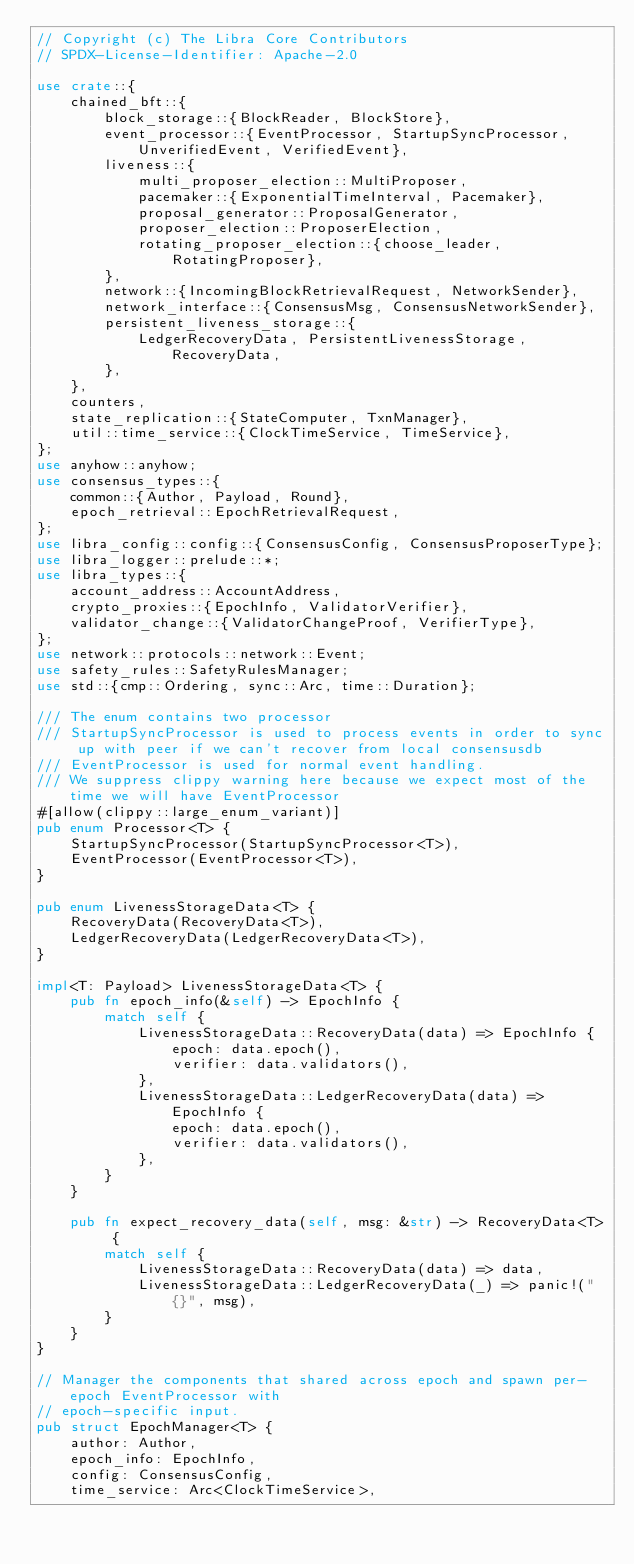<code> <loc_0><loc_0><loc_500><loc_500><_Rust_>// Copyright (c) The Libra Core Contributors
// SPDX-License-Identifier: Apache-2.0

use crate::{
    chained_bft::{
        block_storage::{BlockReader, BlockStore},
        event_processor::{EventProcessor, StartupSyncProcessor, UnverifiedEvent, VerifiedEvent},
        liveness::{
            multi_proposer_election::MultiProposer,
            pacemaker::{ExponentialTimeInterval, Pacemaker},
            proposal_generator::ProposalGenerator,
            proposer_election::ProposerElection,
            rotating_proposer_election::{choose_leader, RotatingProposer},
        },
        network::{IncomingBlockRetrievalRequest, NetworkSender},
        network_interface::{ConsensusMsg, ConsensusNetworkSender},
        persistent_liveness_storage::{
            LedgerRecoveryData, PersistentLivenessStorage, RecoveryData,
        },
    },
    counters,
    state_replication::{StateComputer, TxnManager},
    util::time_service::{ClockTimeService, TimeService},
};
use anyhow::anyhow;
use consensus_types::{
    common::{Author, Payload, Round},
    epoch_retrieval::EpochRetrievalRequest,
};
use libra_config::config::{ConsensusConfig, ConsensusProposerType};
use libra_logger::prelude::*;
use libra_types::{
    account_address::AccountAddress,
    crypto_proxies::{EpochInfo, ValidatorVerifier},
    validator_change::{ValidatorChangeProof, VerifierType},
};
use network::protocols::network::Event;
use safety_rules::SafetyRulesManager;
use std::{cmp::Ordering, sync::Arc, time::Duration};

/// The enum contains two processor
/// StartupSyncProcessor is used to process events in order to sync up with peer if we can't recover from local consensusdb
/// EventProcessor is used for normal event handling.
/// We suppress clippy warning here because we expect most of the time we will have EventProcessor
#[allow(clippy::large_enum_variant)]
pub enum Processor<T> {
    StartupSyncProcessor(StartupSyncProcessor<T>),
    EventProcessor(EventProcessor<T>),
}

pub enum LivenessStorageData<T> {
    RecoveryData(RecoveryData<T>),
    LedgerRecoveryData(LedgerRecoveryData<T>),
}

impl<T: Payload> LivenessStorageData<T> {
    pub fn epoch_info(&self) -> EpochInfo {
        match self {
            LivenessStorageData::RecoveryData(data) => EpochInfo {
                epoch: data.epoch(),
                verifier: data.validators(),
            },
            LivenessStorageData::LedgerRecoveryData(data) => EpochInfo {
                epoch: data.epoch(),
                verifier: data.validators(),
            },
        }
    }

    pub fn expect_recovery_data(self, msg: &str) -> RecoveryData<T> {
        match self {
            LivenessStorageData::RecoveryData(data) => data,
            LivenessStorageData::LedgerRecoveryData(_) => panic!("{}", msg),
        }
    }
}

// Manager the components that shared across epoch and spawn per-epoch EventProcessor with
// epoch-specific input.
pub struct EpochManager<T> {
    author: Author,
    epoch_info: EpochInfo,
    config: ConsensusConfig,
    time_service: Arc<ClockTimeService>,</code> 